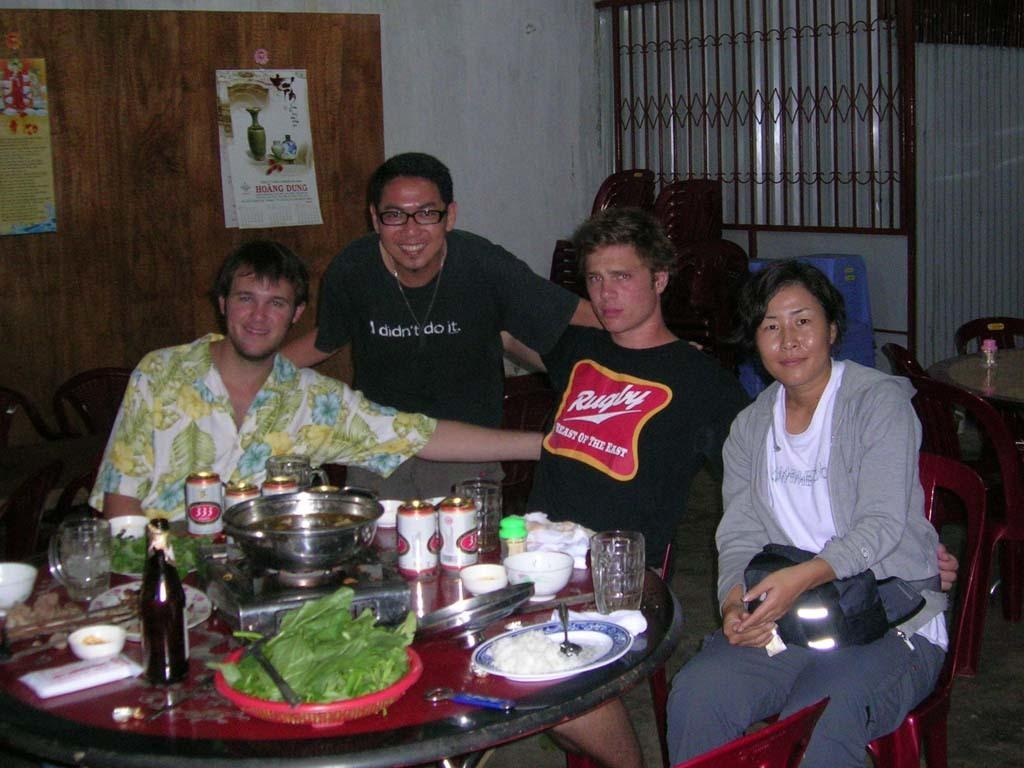How many people are present in the image? There are four people in the image. What is the location of the people in the image? The people are in front of a table. What can be found on the table in the image? The table has eatables and drinks on it. Is there a beggar asking for food in the image? There is no beggar present in the image. What type of cakes are being served on the table in the image? The image does not specify the type of eatables on the table, so it cannot be determined if there are cakes. 